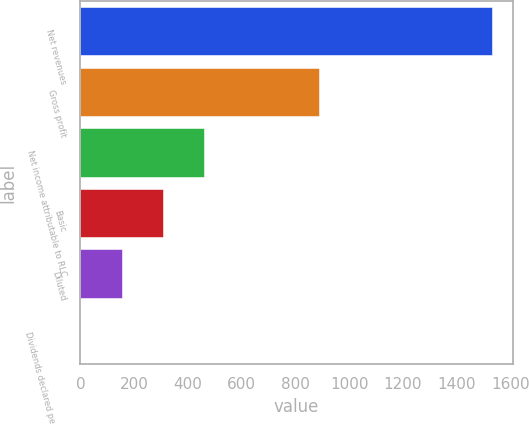Convert chart. <chart><loc_0><loc_0><loc_500><loc_500><bar_chart><fcel>Net revenues<fcel>Gross profit<fcel>Net income attributable to RLC<fcel>Basic<fcel>Diluted<fcel>Dividends declared per common<nl><fcel>1532.1<fcel>887.9<fcel>459.7<fcel>306.5<fcel>153.3<fcel>0.1<nl></chart> 